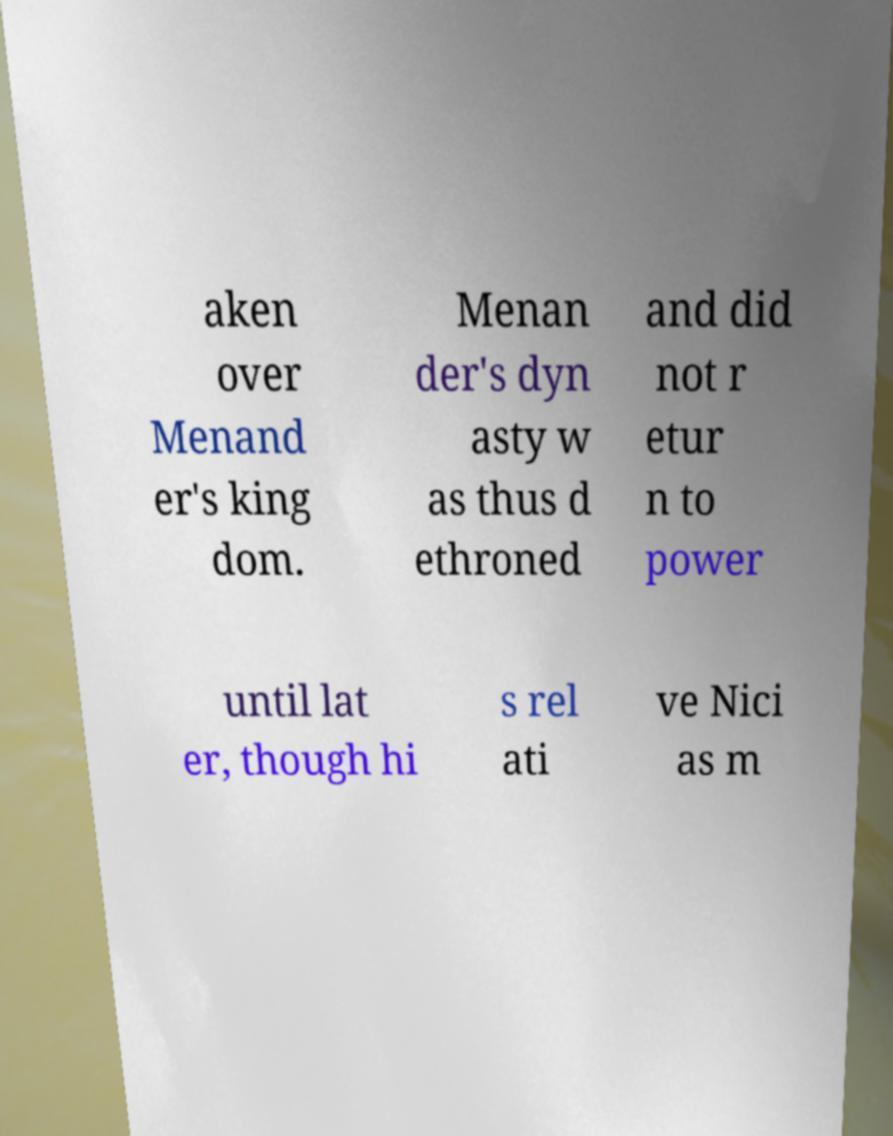I need the written content from this picture converted into text. Can you do that? aken over Menand er's king dom. Menan der's dyn asty w as thus d ethroned and did not r etur n to power until lat er, though hi s rel ati ve Nici as m 